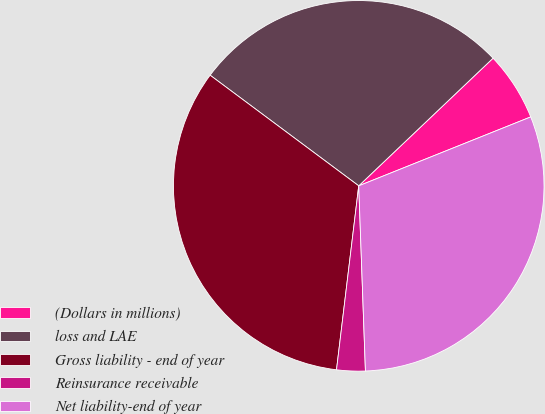<chart> <loc_0><loc_0><loc_500><loc_500><pie_chart><fcel>(Dollars in millions)<fcel>loss and LAE<fcel>Gross liability - end of year<fcel>Reinsurance receivable<fcel>Net liability-end of year<nl><fcel>6.03%<fcel>27.72%<fcel>33.27%<fcel>2.49%<fcel>30.49%<nl></chart> 